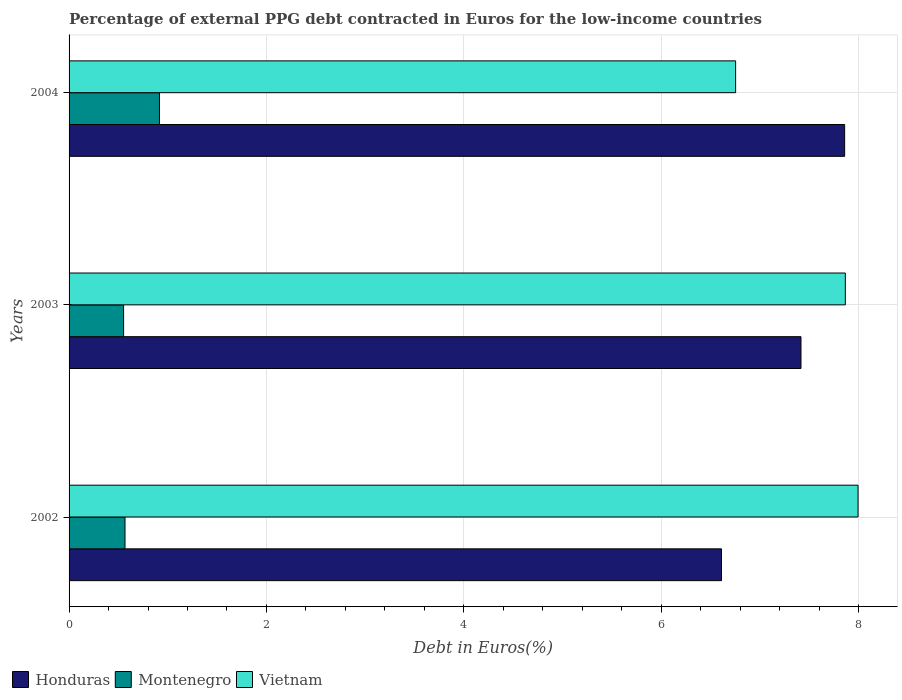How many different coloured bars are there?
Offer a terse response. 3. Are the number of bars on each tick of the Y-axis equal?
Keep it short and to the point. Yes. How many bars are there on the 2nd tick from the bottom?
Keep it short and to the point. 3. What is the label of the 3rd group of bars from the top?
Provide a short and direct response. 2002. In how many cases, is the number of bars for a given year not equal to the number of legend labels?
Offer a very short reply. 0. What is the percentage of external PPG debt contracted in Euros in Montenegro in 2002?
Give a very brief answer. 0.57. Across all years, what is the maximum percentage of external PPG debt contracted in Euros in Vietnam?
Give a very brief answer. 7.99. Across all years, what is the minimum percentage of external PPG debt contracted in Euros in Montenegro?
Provide a short and direct response. 0.55. In which year was the percentage of external PPG debt contracted in Euros in Honduras maximum?
Provide a short and direct response. 2004. In which year was the percentage of external PPG debt contracted in Euros in Honduras minimum?
Offer a terse response. 2002. What is the total percentage of external PPG debt contracted in Euros in Vietnam in the graph?
Your answer should be compact. 22.61. What is the difference between the percentage of external PPG debt contracted in Euros in Montenegro in 2003 and that in 2004?
Provide a short and direct response. -0.36. What is the difference between the percentage of external PPG debt contracted in Euros in Honduras in 2003 and the percentage of external PPG debt contracted in Euros in Vietnam in 2002?
Your response must be concise. -0.58. What is the average percentage of external PPG debt contracted in Euros in Vietnam per year?
Provide a short and direct response. 7.54. In the year 2004, what is the difference between the percentage of external PPG debt contracted in Euros in Montenegro and percentage of external PPG debt contracted in Euros in Vietnam?
Ensure brevity in your answer.  -5.84. What is the ratio of the percentage of external PPG debt contracted in Euros in Vietnam in 2002 to that in 2004?
Ensure brevity in your answer.  1.18. Is the difference between the percentage of external PPG debt contracted in Euros in Montenegro in 2002 and 2004 greater than the difference between the percentage of external PPG debt contracted in Euros in Vietnam in 2002 and 2004?
Provide a short and direct response. No. What is the difference between the highest and the second highest percentage of external PPG debt contracted in Euros in Vietnam?
Give a very brief answer. 0.13. What is the difference between the highest and the lowest percentage of external PPG debt contracted in Euros in Vietnam?
Your answer should be very brief. 1.24. What does the 3rd bar from the top in 2002 represents?
Offer a very short reply. Honduras. What does the 3rd bar from the bottom in 2003 represents?
Provide a short and direct response. Vietnam. Are the values on the major ticks of X-axis written in scientific E-notation?
Keep it short and to the point. No. How many legend labels are there?
Give a very brief answer. 3. What is the title of the graph?
Make the answer very short. Percentage of external PPG debt contracted in Euros for the low-income countries. Does "Isle of Man" appear as one of the legend labels in the graph?
Offer a very short reply. No. What is the label or title of the X-axis?
Offer a terse response. Debt in Euros(%). What is the label or title of the Y-axis?
Keep it short and to the point. Years. What is the Debt in Euros(%) of Honduras in 2002?
Provide a short and direct response. 6.61. What is the Debt in Euros(%) of Montenegro in 2002?
Your answer should be compact. 0.57. What is the Debt in Euros(%) of Vietnam in 2002?
Provide a succinct answer. 7.99. What is the Debt in Euros(%) of Honduras in 2003?
Give a very brief answer. 7.42. What is the Debt in Euros(%) of Montenegro in 2003?
Provide a short and direct response. 0.55. What is the Debt in Euros(%) of Vietnam in 2003?
Your answer should be very brief. 7.87. What is the Debt in Euros(%) in Honduras in 2004?
Provide a short and direct response. 7.86. What is the Debt in Euros(%) of Montenegro in 2004?
Ensure brevity in your answer.  0.92. What is the Debt in Euros(%) of Vietnam in 2004?
Keep it short and to the point. 6.75. Across all years, what is the maximum Debt in Euros(%) in Honduras?
Keep it short and to the point. 7.86. Across all years, what is the maximum Debt in Euros(%) of Montenegro?
Offer a very short reply. 0.92. Across all years, what is the maximum Debt in Euros(%) of Vietnam?
Ensure brevity in your answer.  7.99. Across all years, what is the minimum Debt in Euros(%) in Honduras?
Offer a terse response. 6.61. Across all years, what is the minimum Debt in Euros(%) of Montenegro?
Offer a very short reply. 0.55. Across all years, what is the minimum Debt in Euros(%) of Vietnam?
Provide a succinct answer. 6.75. What is the total Debt in Euros(%) of Honduras in the graph?
Give a very brief answer. 21.88. What is the total Debt in Euros(%) of Montenegro in the graph?
Ensure brevity in your answer.  2.04. What is the total Debt in Euros(%) in Vietnam in the graph?
Give a very brief answer. 22.61. What is the difference between the Debt in Euros(%) in Honduras in 2002 and that in 2003?
Your answer should be compact. -0.81. What is the difference between the Debt in Euros(%) of Montenegro in 2002 and that in 2003?
Your answer should be compact. 0.01. What is the difference between the Debt in Euros(%) of Vietnam in 2002 and that in 2003?
Provide a succinct answer. 0.13. What is the difference between the Debt in Euros(%) of Honduras in 2002 and that in 2004?
Make the answer very short. -1.25. What is the difference between the Debt in Euros(%) of Montenegro in 2002 and that in 2004?
Your answer should be compact. -0.35. What is the difference between the Debt in Euros(%) in Vietnam in 2002 and that in 2004?
Your response must be concise. 1.24. What is the difference between the Debt in Euros(%) of Honduras in 2003 and that in 2004?
Offer a terse response. -0.44. What is the difference between the Debt in Euros(%) of Montenegro in 2003 and that in 2004?
Your answer should be very brief. -0.36. What is the difference between the Debt in Euros(%) of Vietnam in 2003 and that in 2004?
Your response must be concise. 1.11. What is the difference between the Debt in Euros(%) of Honduras in 2002 and the Debt in Euros(%) of Montenegro in 2003?
Your answer should be very brief. 6.06. What is the difference between the Debt in Euros(%) of Honduras in 2002 and the Debt in Euros(%) of Vietnam in 2003?
Ensure brevity in your answer.  -1.25. What is the difference between the Debt in Euros(%) in Montenegro in 2002 and the Debt in Euros(%) in Vietnam in 2003?
Provide a succinct answer. -7.3. What is the difference between the Debt in Euros(%) of Honduras in 2002 and the Debt in Euros(%) of Montenegro in 2004?
Provide a short and direct response. 5.69. What is the difference between the Debt in Euros(%) of Honduras in 2002 and the Debt in Euros(%) of Vietnam in 2004?
Keep it short and to the point. -0.14. What is the difference between the Debt in Euros(%) in Montenegro in 2002 and the Debt in Euros(%) in Vietnam in 2004?
Make the answer very short. -6.19. What is the difference between the Debt in Euros(%) in Honduras in 2003 and the Debt in Euros(%) in Montenegro in 2004?
Keep it short and to the point. 6.5. What is the difference between the Debt in Euros(%) in Honduras in 2003 and the Debt in Euros(%) in Vietnam in 2004?
Your answer should be compact. 0.66. What is the difference between the Debt in Euros(%) in Montenegro in 2003 and the Debt in Euros(%) in Vietnam in 2004?
Provide a succinct answer. -6.2. What is the average Debt in Euros(%) in Honduras per year?
Give a very brief answer. 7.29. What is the average Debt in Euros(%) in Montenegro per year?
Provide a succinct answer. 0.68. What is the average Debt in Euros(%) of Vietnam per year?
Your answer should be very brief. 7.54. In the year 2002, what is the difference between the Debt in Euros(%) in Honduras and Debt in Euros(%) in Montenegro?
Your answer should be very brief. 6.04. In the year 2002, what is the difference between the Debt in Euros(%) of Honduras and Debt in Euros(%) of Vietnam?
Your answer should be compact. -1.38. In the year 2002, what is the difference between the Debt in Euros(%) in Montenegro and Debt in Euros(%) in Vietnam?
Provide a short and direct response. -7.43. In the year 2003, what is the difference between the Debt in Euros(%) of Honduras and Debt in Euros(%) of Montenegro?
Give a very brief answer. 6.86. In the year 2003, what is the difference between the Debt in Euros(%) of Honduras and Debt in Euros(%) of Vietnam?
Give a very brief answer. -0.45. In the year 2003, what is the difference between the Debt in Euros(%) of Montenegro and Debt in Euros(%) of Vietnam?
Your answer should be compact. -7.31. In the year 2004, what is the difference between the Debt in Euros(%) in Honduras and Debt in Euros(%) in Montenegro?
Make the answer very short. 6.94. In the year 2004, what is the difference between the Debt in Euros(%) in Honduras and Debt in Euros(%) in Vietnam?
Provide a short and direct response. 1.1. In the year 2004, what is the difference between the Debt in Euros(%) in Montenegro and Debt in Euros(%) in Vietnam?
Offer a terse response. -5.84. What is the ratio of the Debt in Euros(%) in Honduras in 2002 to that in 2003?
Provide a short and direct response. 0.89. What is the ratio of the Debt in Euros(%) in Montenegro in 2002 to that in 2003?
Keep it short and to the point. 1.03. What is the ratio of the Debt in Euros(%) in Vietnam in 2002 to that in 2003?
Your answer should be very brief. 1.02. What is the ratio of the Debt in Euros(%) in Honduras in 2002 to that in 2004?
Keep it short and to the point. 0.84. What is the ratio of the Debt in Euros(%) in Montenegro in 2002 to that in 2004?
Provide a short and direct response. 0.62. What is the ratio of the Debt in Euros(%) in Vietnam in 2002 to that in 2004?
Give a very brief answer. 1.18. What is the ratio of the Debt in Euros(%) of Honduras in 2003 to that in 2004?
Offer a very short reply. 0.94. What is the ratio of the Debt in Euros(%) of Montenegro in 2003 to that in 2004?
Your response must be concise. 0.6. What is the ratio of the Debt in Euros(%) of Vietnam in 2003 to that in 2004?
Ensure brevity in your answer.  1.16. What is the difference between the highest and the second highest Debt in Euros(%) in Honduras?
Offer a very short reply. 0.44. What is the difference between the highest and the second highest Debt in Euros(%) in Montenegro?
Your answer should be very brief. 0.35. What is the difference between the highest and the second highest Debt in Euros(%) of Vietnam?
Ensure brevity in your answer.  0.13. What is the difference between the highest and the lowest Debt in Euros(%) of Honduras?
Ensure brevity in your answer.  1.25. What is the difference between the highest and the lowest Debt in Euros(%) of Montenegro?
Ensure brevity in your answer.  0.36. What is the difference between the highest and the lowest Debt in Euros(%) of Vietnam?
Your answer should be very brief. 1.24. 